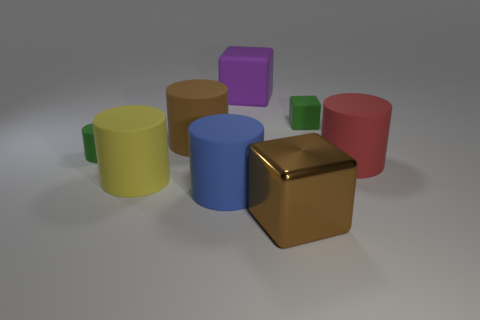Are there any yellow cylinders of the same size as the purple object?
Keep it short and to the point. Yes. What number of blue things are either big rubber spheres or big matte things?
Make the answer very short. 1. How many large cubes are the same color as the large shiny object?
Give a very brief answer. 0. Are there any other things that are the same shape as the big yellow thing?
Offer a very short reply. Yes. What number of balls are either big purple things or big blue rubber things?
Provide a succinct answer. 0. What is the color of the large matte cylinder that is behind the green cylinder?
Offer a very short reply. Brown. What shape is the shiny thing that is the same size as the purple block?
Keep it short and to the point. Cube. There is a green cylinder; what number of big purple cubes are in front of it?
Provide a short and direct response. 0. How many objects are large yellow cylinders or tiny green cylinders?
Your response must be concise. 2. The big matte thing that is both left of the red thing and to the right of the blue matte thing has what shape?
Provide a succinct answer. Cube. 